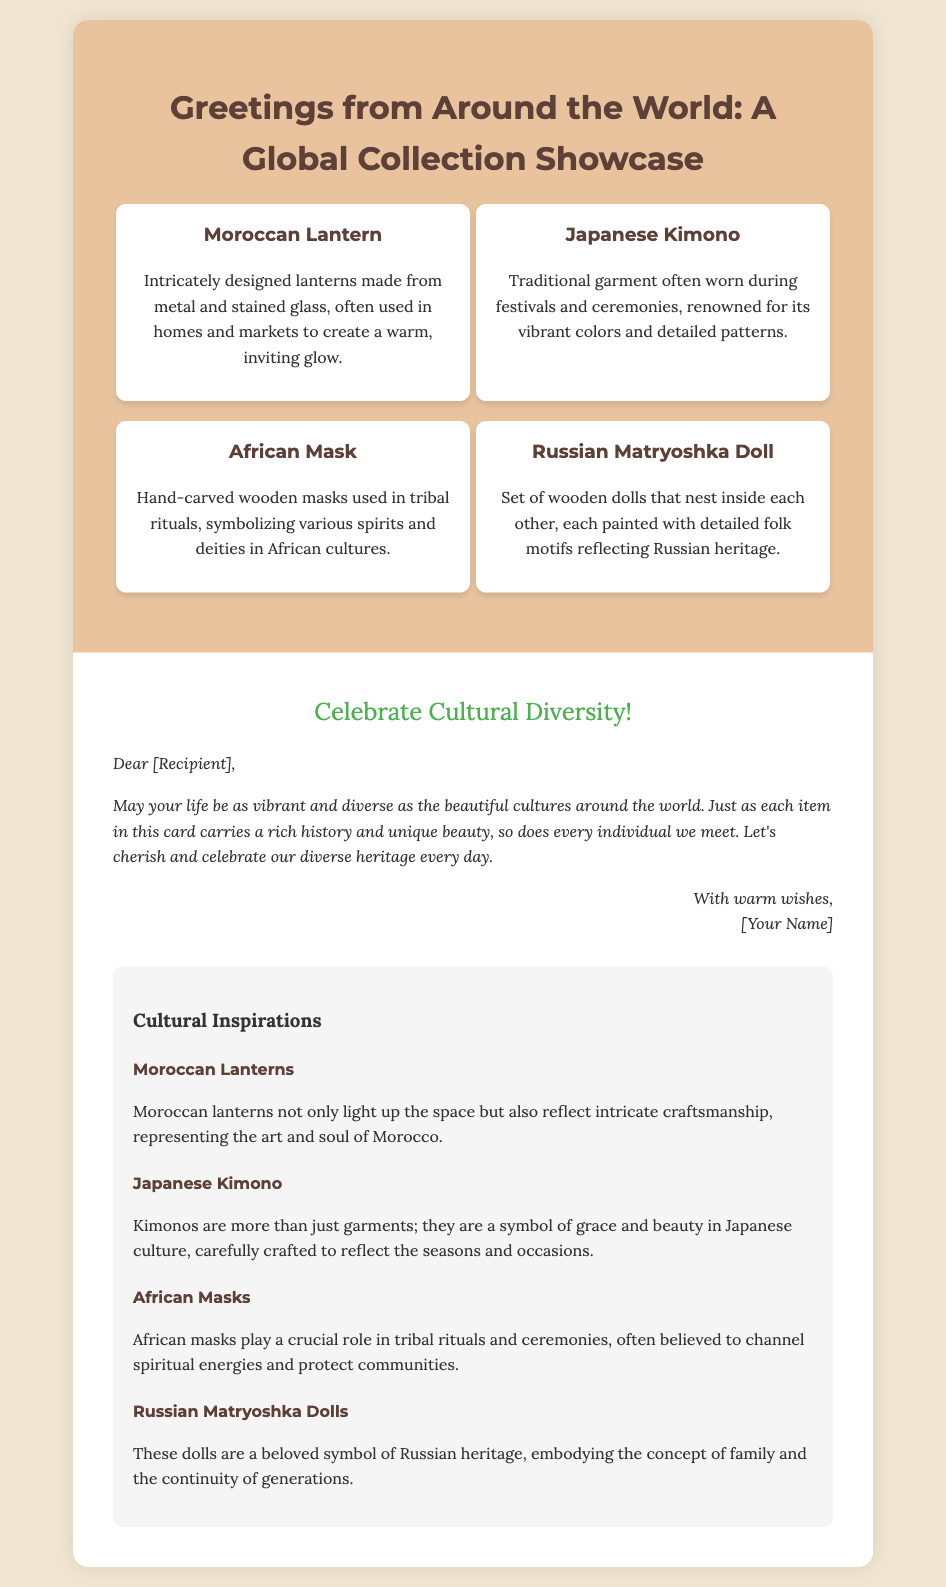What is the title of the card? The title of the card is displayed prominently at the top of the rendered document.
Answer: Greetings from Around the World: A Global Collection Showcase How many cultural items are featured in the collage? The collage section includes four distinct cultural items as described in the document.
Answer: Four What is the first cultural item listed? The first cultural item is the first item mentioned in the collage section of the card.
Answer: Moroccan Lantern What color is used for the greeting message? The color specified for the greeting message is highlighted in the styling within the document.
Answer: Green What does the Brazilian-style greeting message promote? The greeting message conveys an encouragement regarding a core theme presented in the document.
Answer: Cultural Diversity What do African masks symbolize in the document? A specific explanation is provided in the context of cultural significance within the text regarding the African masks.
Answer: Spiritual energies Who is the greeting message addressed to? The message includes a salutation directed towards the recipient indicated in the greeting.
Answer: [Recipient] What material are Russian Matryoshka dolls made from? The specific material mentioned in the description of the Russian Matryoshka dolls can be identified in the text.
Answer: Wood What is the tone of the message signed by the sender? The tone of the message is reflected in the way the closing is crafted at the end of the card.
Answer: Warm 